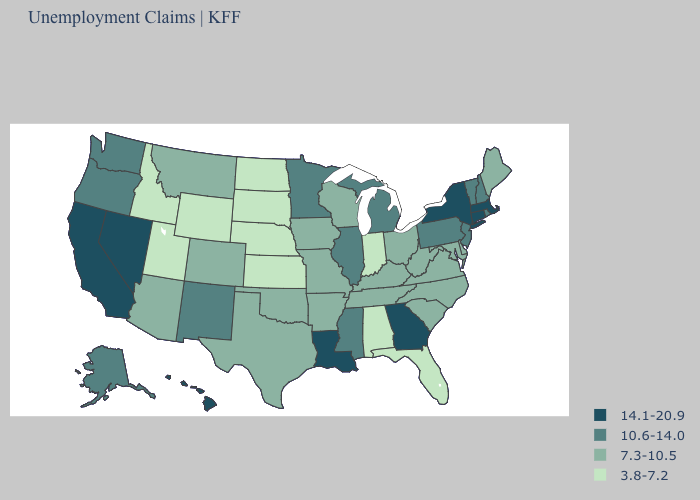Name the states that have a value in the range 10.6-14.0?
Be succinct. Alaska, Illinois, Michigan, Minnesota, Mississippi, New Hampshire, New Jersey, New Mexico, Oregon, Pennsylvania, Rhode Island, Vermont, Washington. Does Georgia have the highest value in the USA?
Concise answer only. Yes. Does the first symbol in the legend represent the smallest category?
Answer briefly. No. What is the highest value in states that border South Carolina?
Be succinct. 14.1-20.9. Does the first symbol in the legend represent the smallest category?
Short answer required. No. What is the value of Mississippi?
Be succinct. 10.6-14.0. What is the highest value in the USA?
Short answer required. 14.1-20.9. What is the lowest value in states that border Rhode Island?
Write a very short answer. 14.1-20.9. Does the map have missing data?
Write a very short answer. No. Name the states that have a value in the range 3.8-7.2?
Be succinct. Alabama, Florida, Idaho, Indiana, Kansas, Nebraska, North Dakota, South Dakota, Utah, Wyoming. Does Kansas have the lowest value in the MidWest?
Short answer required. Yes. What is the highest value in the South ?
Write a very short answer. 14.1-20.9. Does the first symbol in the legend represent the smallest category?
Quick response, please. No. What is the value of Rhode Island?
Keep it brief. 10.6-14.0. What is the value of New Jersey?
Write a very short answer. 10.6-14.0. 